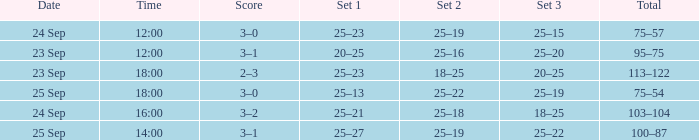What was the score when the time was 14:00? 3–1. 